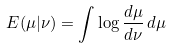<formula> <loc_0><loc_0><loc_500><loc_500>E ( \mu | \nu ) = \int \log \frac { d \mu } { d \nu } \, d \mu</formula> 